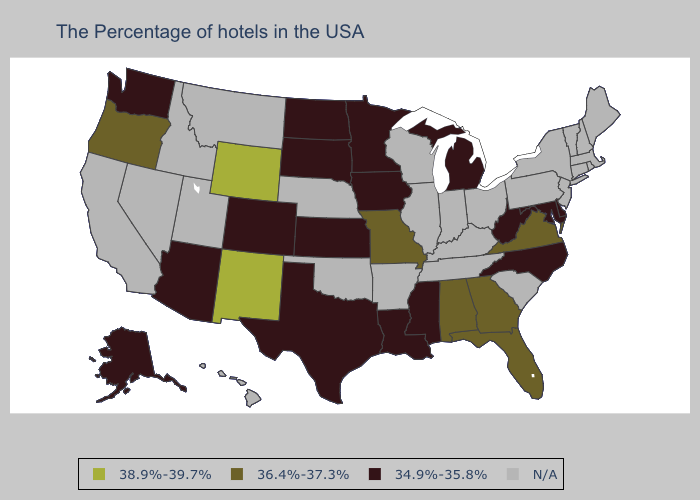Among the states that border South Carolina , which have the highest value?
Quick response, please. Georgia. Name the states that have a value in the range 34.9%-35.8%?
Answer briefly. Delaware, Maryland, North Carolina, West Virginia, Michigan, Mississippi, Louisiana, Minnesota, Iowa, Kansas, Texas, South Dakota, North Dakota, Colorado, Arizona, Washington, Alaska. Name the states that have a value in the range 38.9%-39.7%?
Give a very brief answer. Wyoming, New Mexico. Which states have the highest value in the USA?
Short answer required. Wyoming, New Mexico. Name the states that have a value in the range 38.9%-39.7%?
Keep it brief. Wyoming, New Mexico. Does the first symbol in the legend represent the smallest category?
Concise answer only. No. What is the highest value in states that border North Dakota?
Be succinct. 34.9%-35.8%. What is the lowest value in the MidWest?
Keep it brief. 34.9%-35.8%. What is the value of Florida?
Keep it brief. 36.4%-37.3%. Which states have the lowest value in the USA?
Concise answer only. Delaware, Maryland, North Carolina, West Virginia, Michigan, Mississippi, Louisiana, Minnesota, Iowa, Kansas, Texas, South Dakota, North Dakota, Colorado, Arizona, Washington, Alaska. Does Missouri have the highest value in the MidWest?
Keep it brief. Yes. What is the value of Hawaii?
Concise answer only. N/A. 